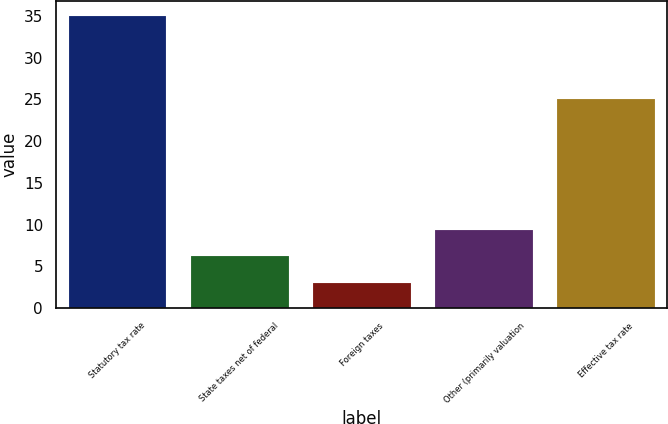<chart> <loc_0><loc_0><loc_500><loc_500><bar_chart><fcel>Statutory tax rate<fcel>State taxes net of federal<fcel>Foreign taxes<fcel>Other (primarily valuation<fcel>Effective tax rate<nl><fcel>35<fcel>6.2<fcel>3<fcel>9.4<fcel>25<nl></chart> 